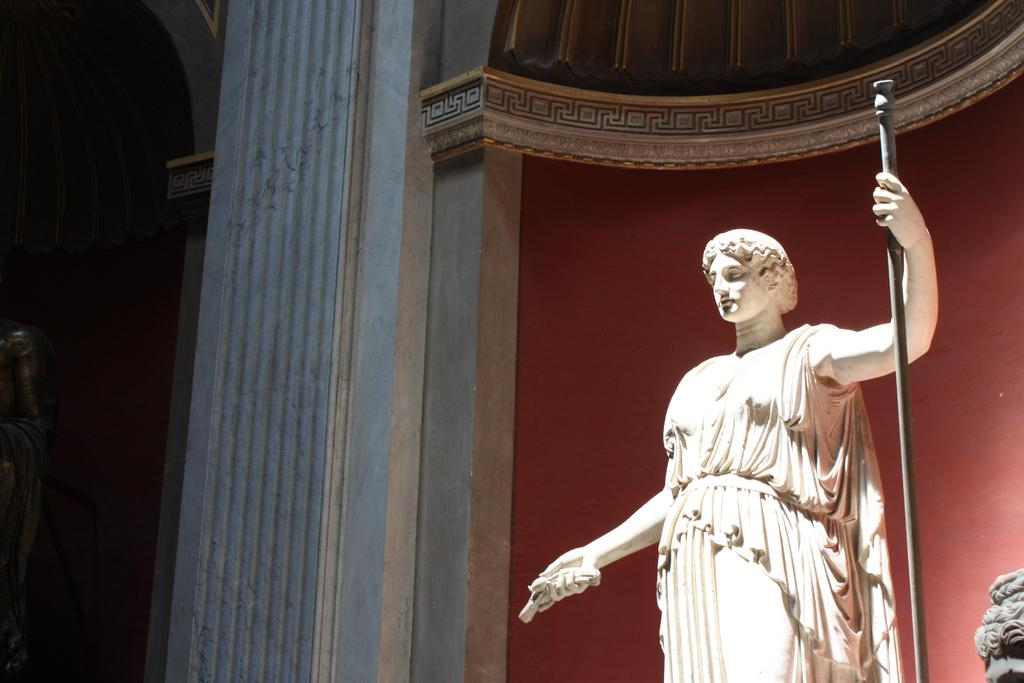What is the main subject of the image? There is a sculpture in the image. Can you describe the appearance of the sculpture? The sculpture is white in color. What can be seen in the background of the image? There is a wall and a pillar in the background of the image. What type of instrument is being played in the image? There is no instrument present in the image; it features a white sculpture and a background with a wall and a pillar. 